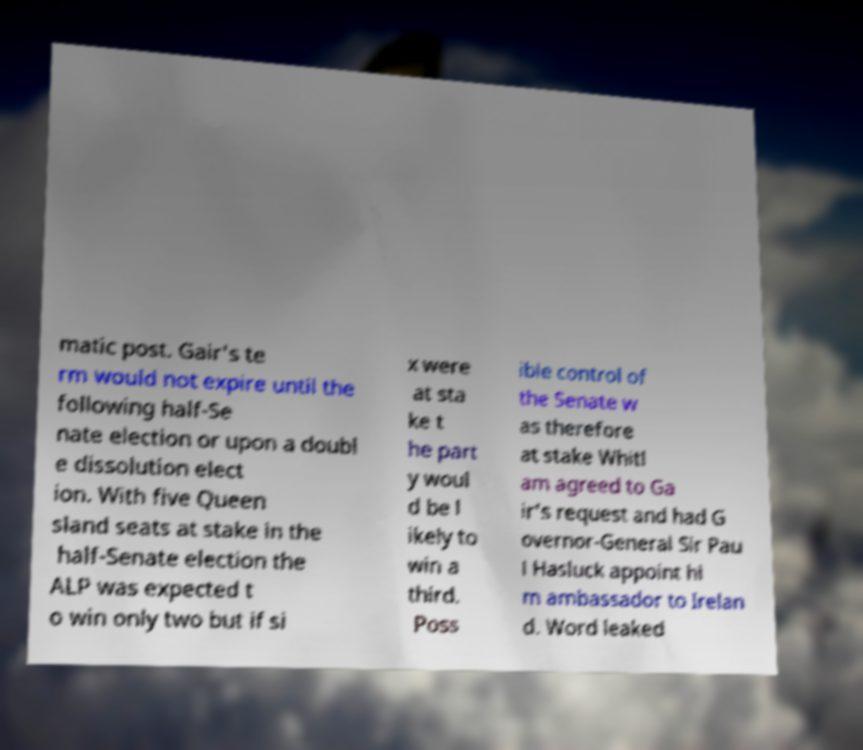Can you read and provide the text displayed in the image?This photo seems to have some interesting text. Can you extract and type it out for me? matic post. Gair's te rm would not expire until the following half-Se nate election or upon a doubl e dissolution elect ion. With five Queen sland seats at stake in the half-Senate election the ALP was expected t o win only two but if si x were at sta ke t he part y woul d be l ikely to win a third. Poss ible control of the Senate w as therefore at stake Whitl am agreed to Ga ir's request and had G overnor-General Sir Pau l Hasluck appoint hi m ambassador to Irelan d. Word leaked 